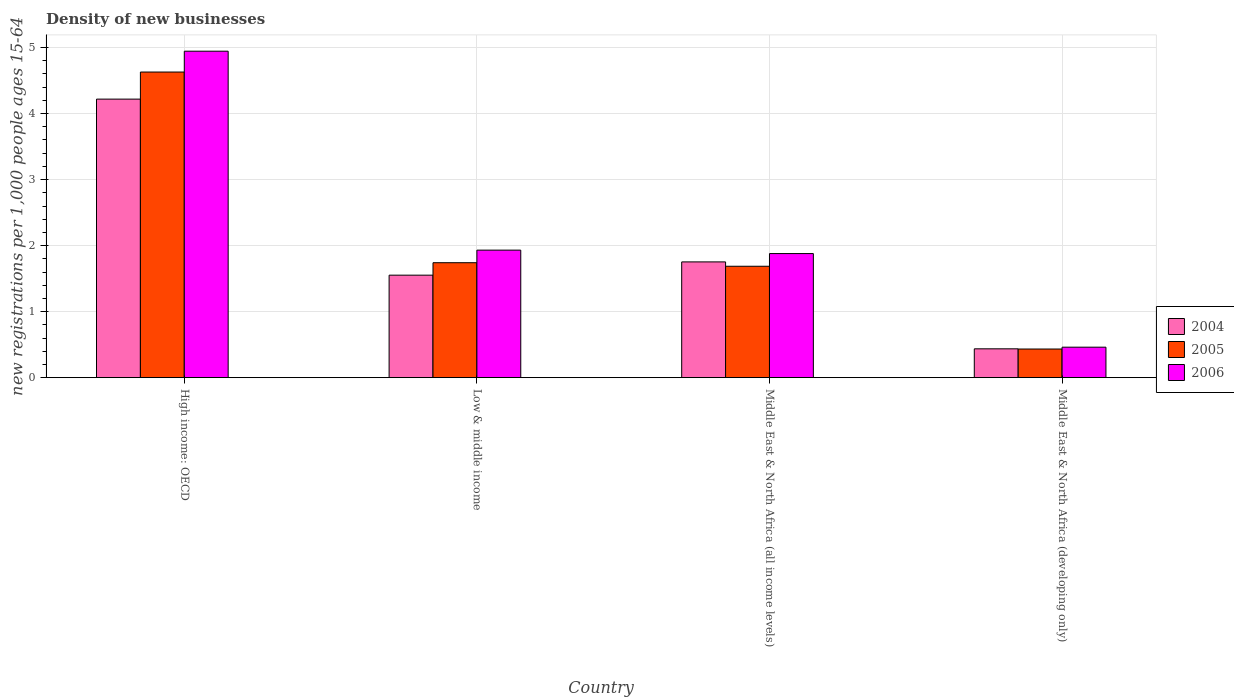Are the number of bars per tick equal to the number of legend labels?
Your answer should be compact. Yes. How many bars are there on the 4th tick from the right?
Provide a succinct answer. 3. What is the label of the 1st group of bars from the left?
Your response must be concise. High income: OECD. What is the number of new registrations in 2006 in Middle East & North Africa (developing only)?
Provide a succinct answer. 0.46. Across all countries, what is the maximum number of new registrations in 2006?
Make the answer very short. 4.94. Across all countries, what is the minimum number of new registrations in 2006?
Your answer should be compact. 0.46. In which country was the number of new registrations in 2006 maximum?
Offer a very short reply. High income: OECD. In which country was the number of new registrations in 2005 minimum?
Your answer should be compact. Middle East & North Africa (developing only). What is the total number of new registrations in 2004 in the graph?
Offer a very short reply. 7.96. What is the difference between the number of new registrations in 2005 in Low & middle income and that in Middle East & North Africa (all income levels)?
Offer a very short reply. 0.05. What is the difference between the number of new registrations in 2006 in Middle East & North Africa (all income levels) and the number of new registrations in 2004 in Middle East & North Africa (developing only)?
Give a very brief answer. 1.44. What is the average number of new registrations in 2005 per country?
Ensure brevity in your answer.  2.12. What is the difference between the number of new registrations of/in 2004 and number of new registrations of/in 2005 in Middle East & North Africa (developing only)?
Keep it short and to the point. 0. In how many countries, is the number of new registrations in 2004 greater than 2.6?
Keep it short and to the point. 1. What is the ratio of the number of new registrations in 2004 in Middle East & North Africa (all income levels) to that in Middle East & North Africa (developing only)?
Give a very brief answer. 4.01. Is the difference between the number of new registrations in 2004 in High income: OECD and Middle East & North Africa (developing only) greater than the difference between the number of new registrations in 2005 in High income: OECD and Middle East & North Africa (developing only)?
Ensure brevity in your answer.  No. What is the difference between the highest and the second highest number of new registrations in 2004?
Ensure brevity in your answer.  -2.47. What is the difference between the highest and the lowest number of new registrations in 2004?
Make the answer very short. 3.78. In how many countries, is the number of new registrations in 2005 greater than the average number of new registrations in 2005 taken over all countries?
Offer a terse response. 1. Is the sum of the number of new registrations in 2005 in High income: OECD and Middle East & North Africa (developing only) greater than the maximum number of new registrations in 2004 across all countries?
Make the answer very short. Yes. What does the 2nd bar from the right in High income: OECD represents?
Offer a terse response. 2005. Is it the case that in every country, the sum of the number of new registrations in 2004 and number of new registrations in 2006 is greater than the number of new registrations in 2005?
Your answer should be very brief. Yes. How many countries are there in the graph?
Provide a succinct answer. 4. What is the difference between two consecutive major ticks on the Y-axis?
Your answer should be very brief. 1. Are the values on the major ticks of Y-axis written in scientific E-notation?
Offer a terse response. No. Does the graph contain any zero values?
Provide a succinct answer. No. Does the graph contain grids?
Make the answer very short. Yes. Where does the legend appear in the graph?
Provide a short and direct response. Center right. How are the legend labels stacked?
Ensure brevity in your answer.  Vertical. What is the title of the graph?
Your answer should be compact. Density of new businesses. Does "1963" appear as one of the legend labels in the graph?
Provide a short and direct response. No. What is the label or title of the X-axis?
Provide a short and direct response. Country. What is the label or title of the Y-axis?
Give a very brief answer. New registrations per 1,0 people ages 15-64. What is the new registrations per 1,000 people ages 15-64 of 2004 in High income: OECD?
Offer a terse response. 4.22. What is the new registrations per 1,000 people ages 15-64 of 2005 in High income: OECD?
Offer a terse response. 4.63. What is the new registrations per 1,000 people ages 15-64 in 2006 in High income: OECD?
Provide a succinct answer. 4.94. What is the new registrations per 1,000 people ages 15-64 in 2004 in Low & middle income?
Ensure brevity in your answer.  1.55. What is the new registrations per 1,000 people ages 15-64 of 2005 in Low & middle income?
Offer a very short reply. 1.74. What is the new registrations per 1,000 people ages 15-64 in 2006 in Low & middle income?
Your answer should be compact. 1.93. What is the new registrations per 1,000 people ages 15-64 in 2004 in Middle East & North Africa (all income levels)?
Offer a very short reply. 1.75. What is the new registrations per 1,000 people ages 15-64 of 2005 in Middle East & North Africa (all income levels)?
Give a very brief answer. 1.69. What is the new registrations per 1,000 people ages 15-64 of 2006 in Middle East & North Africa (all income levels)?
Offer a very short reply. 1.88. What is the new registrations per 1,000 people ages 15-64 in 2004 in Middle East & North Africa (developing only)?
Your response must be concise. 0.44. What is the new registrations per 1,000 people ages 15-64 of 2005 in Middle East & North Africa (developing only)?
Keep it short and to the point. 0.43. What is the new registrations per 1,000 people ages 15-64 of 2006 in Middle East & North Africa (developing only)?
Make the answer very short. 0.46. Across all countries, what is the maximum new registrations per 1,000 people ages 15-64 in 2004?
Offer a very short reply. 4.22. Across all countries, what is the maximum new registrations per 1,000 people ages 15-64 in 2005?
Provide a succinct answer. 4.63. Across all countries, what is the maximum new registrations per 1,000 people ages 15-64 of 2006?
Keep it short and to the point. 4.94. Across all countries, what is the minimum new registrations per 1,000 people ages 15-64 of 2004?
Your answer should be compact. 0.44. Across all countries, what is the minimum new registrations per 1,000 people ages 15-64 in 2005?
Give a very brief answer. 0.43. Across all countries, what is the minimum new registrations per 1,000 people ages 15-64 of 2006?
Offer a terse response. 0.46. What is the total new registrations per 1,000 people ages 15-64 of 2004 in the graph?
Your response must be concise. 7.96. What is the total new registrations per 1,000 people ages 15-64 in 2005 in the graph?
Keep it short and to the point. 8.49. What is the total new registrations per 1,000 people ages 15-64 of 2006 in the graph?
Ensure brevity in your answer.  9.22. What is the difference between the new registrations per 1,000 people ages 15-64 in 2004 in High income: OECD and that in Low & middle income?
Make the answer very short. 2.67. What is the difference between the new registrations per 1,000 people ages 15-64 of 2005 in High income: OECD and that in Low & middle income?
Provide a succinct answer. 2.89. What is the difference between the new registrations per 1,000 people ages 15-64 in 2006 in High income: OECD and that in Low & middle income?
Offer a terse response. 3.01. What is the difference between the new registrations per 1,000 people ages 15-64 in 2004 in High income: OECD and that in Middle East & North Africa (all income levels)?
Your answer should be compact. 2.47. What is the difference between the new registrations per 1,000 people ages 15-64 of 2005 in High income: OECD and that in Middle East & North Africa (all income levels)?
Make the answer very short. 2.94. What is the difference between the new registrations per 1,000 people ages 15-64 in 2006 in High income: OECD and that in Middle East & North Africa (all income levels)?
Give a very brief answer. 3.07. What is the difference between the new registrations per 1,000 people ages 15-64 of 2004 in High income: OECD and that in Middle East & North Africa (developing only)?
Provide a short and direct response. 3.78. What is the difference between the new registrations per 1,000 people ages 15-64 of 2005 in High income: OECD and that in Middle East & North Africa (developing only)?
Provide a short and direct response. 4.2. What is the difference between the new registrations per 1,000 people ages 15-64 in 2006 in High income: OECD and that in Middle East & North Africa (developing only)?
Your answer should be very brief. 4.48. What is the difference between the new registrations per 1,000 people ages 15-64 in 2004 in Low & middle income and that in Middle East & North Africa (all income levels)?
Give a very brief answer. -0.2. What is the difference between the new registrations per 1,000 people ages 15-64 of 2005 in Low & middle income and that in Middle East & North Africa (all income levels)?
Ensure brevity in your answer.  0.05. What is the difference between the new registrations per 1,000 people ages 15-64 in 2006 in Low & middle income and that in Middle East & North Africa (all income levels)?
Offer a terse response. 0.05. What is the difference between the new registrations per 1,000 people ages 15-64 of 2004 in Low & middle income and that in Middle East & North Africa (developing only)?
Ensure brevity in your answer.  1.12. What is the difference between the new registrations per 1,000 people ages 15-64 in 2005 in Low & middle income and that in Middle East & North Africa (developing only)?
Provide a short and direct response. 1.31. What is the difference between the new registrations per 1,000 people ages 15-64 of 2006 in Low & middle income and that in Middle East & North Africa (developing only)?
Provide a succinct answer. 1.47. What is the difference between the new registrations per 1,000 people ages 15-64 of 2004 in Middle East & North Africa (all income levels) and that in Middle East & North Africa (developing only)?
Your answer should be compact. 1.32. What is the difference between the new registrations per 1,000 people ages 15-64 of 2005 in Middle East & North Africa (all income levels) and that in Middle East & North Africa (developing only)?
Offer a very short reply. 1.25. What is the difference between the new registrations per 1,000 people ages 15-64 of 2006 in Middle East & North Africa (all income levels) and that in Middle East & North Africa (developing only)?
Your response must be concise. 1.42. What is the difference between the new registrations per 1,000 people ages 15-64 of 2004 in High income: OECD and the new registrations per 1,000 people ages 15-64 of 2005 in Low & middle income?
Your answer should be compact. 2.48. What is the difference between the new registrations per 1,000 people ages 15-64 of 2004 in High income: OECD and the new registrations per 1,000 people ages 15-64 of 2006 in Low & middle income?
Your response must be concise. 2.29. What is the difference between the new registrations per 1,000 people ages 15-64 in 2005 in High income: OECD and the new registrations per 1,000 people ages 15-64 in 2006 in Low & middle income?
Make the answer very short. 2.7. What is the difference between the new registrations per 1,000 people ages 15-64 of 2004 in High income: OECD and the new registrations per 1,000 people ages 15-64 of 2005 in Middle East & North Africa (all income levels)?
Your response must be concise. 2.53. What is the difference between the new registrations per 1,000 people ages 15-64 of 2004 in High income: OECD and the new registrations per 1,000 people ages 15-64 of 2006 in Middle East & North Africa (all income levels)?
Your answer should be compact. 2.34. What is the difference between the new registrations per 1,000 people ages 15-64 in 2005 in High income: OECD and the new registrations per 1,000 people ages 15-64 in 2006 in Middle East & North Africa (all income levels)?
Your answer should be compact. 2.75. What is the difference between the new registrations per 1,000 people ages 15-64 of 2004 in High income: OECD and the new registrations per 1,000 people ages 15-64 of 2005 in Middle East & North Africa (developing only)?
Your answer should be very brief. 3.79. What is the difference between the new registrations per 1,000 people ages 15-64 in 2004 in High income: OECD and the new registrations per 1,000 people ages 15-64 in 2006 in Middle East & North Africa (developing only)?
Your answer should be very brief. 3.76. What is the difference between the new registrations per 1,000 people ages 15-64 in 2005 in High income: OECD and the new registrations per 1,000 people ages 15-64 in 2006 in Middle East & North Africa (developing only)?
Your answer should be very brief. 4.17. What is the difference between the new registrations per 1,000 people ages 15-64 of 2004 in Low & middle income and the new registrations per 1,000 people ages 15-64 of 2005 in Middle East & North Africa (all income levels)?
Provide a succinct answer. -0.13. What is the difference between the new registrations per 1,000 people ages 15-64 in 2004 in Low & middle income and the new registrations per 1,000 people ages 15-64 in 2006 in Middle East & North Africa (all income levels)?
Give a very brief answer. -0.33. What is the difference between the new registrations per 1,000 people ages 15-64 in 2005 in Low & middle income and the new registrations per 1,000 people ages 15-64 in 2006 in Middle East & North Africa (all income levels)?
Make the answer very short. -0.14. What is the difference between the new registrations per 1,000 people ages 15-64 of 2004 in Low & middle income and the new registrations per 1,000 people ages 15-64 of 2005 in Middle East & North Africa (developing only)?
Give a very brief answer. 1.12. What is the difference between the new registrations per 1,000 people ages 15-64 in 2004 in Low & middle income and the new registrations per 1,000 people ages 15-64 in 2006 in Middle East & North Africa (developing only)?
Keep it short and to the point. 1.09. What is the difference between the new registrations per 1,000 people ages 15-64 in 2005 in Low & middle income and the new registrations per 1,000 people ages 15-64 in 2006 in Middle East & North Africa (developing only)?
Offer a terse response. 1.28. What is the difference between the new registrations per 1,000 people ages 15-64 of 2004 in Middle East & North Africa (all income levels) and the new registrations per 1,000 people ages 15-64 of 2005 in Middle East & North Africa (developing only)?
Ensure brevity in your answer.  1.32. What is the difference between the new registrations per 1,000 people ages 15-64 in 2004 in Middle East & North Africa (all income levels) and the new registrations per 1,000 people ages 15-64 in 2006 in Middle East & North Africa (developing only)?
Your answer should be compact. 1.29. What is the difference between the new registrations per 1,000 people ages 15-64 of 2005 in Middle East & North Africa (all income levels) and the new registrations per 1,000 people ages 15-64 of 2006 in Middle East & North Africa (developing only)?
Provide a short and direct response. 1.23. What is the average new registrations per 1,000 people ages 15-64 of 2004 per country?
Make the answer very short. 1.99. What is the average new registrations per 1,000 people ages 15-64 in 2005 per country?
Ensure brevity in your answer.  2.12. What is the average new registrations per 1,000 people ages 15-64 of 2006 per country?
Your answer should be compact. 2.3. What is the difference between the new registrations per 1,000 people ages 15-64 in 2004 and new registrations per 1,000 people ages 15-64 in 2005 in High income: OECD?
Make the answer very short. -0.41. What is the difference between the new registrations per 1,000 people ages 15-64 of 2004 and new registrations per 1,000 people ages 15-64 of 2006 in High income: OECD?
Provide a succinct answer. -0.73. What is the difference between the new registrations per 1,000 people ages 15-64 in 2005 and new registrations per 1,000 people ages 15-64 in 2006 in High income: OECD?
Provide a succinct answer. -0.32. What is the difference between the new registrations per 1,000 people ages 15-64 of 2004 and new registrations per 1,000 people ages 15-64 of 2005 in Low & middle income?
Offer a terse response. -0.19. What is the difference between the new registrations per 1,000 people ages 15-64 in 2004 and new registrations per 1,000 people ages 15-64 in 2006 in Low & middle income?
Offer a terse response. -0.38. What is the difference between the new registrations per 1,000 people ages 15-64 in 2005 and new registrations per 1,000 people ages 15-64 in 2006 in Low & middle income?
Ensure brevity in your answer.  -0.19. What is the difference between the new registrations per 1,000 people ages 15-64 of 2004 and new registrations per 1,000 people ages 15-64 of 2005 in Middle East & North Africa (all income levels)?
Provide a succinct answer. 0.07. What is the difference between the new registrations per 1,000 people ages 15-64 of 2004 and new registrations per 1,000 people ages 15-64 of 2006 in Middle East & North Africa (all income levels)?
Ensure brevity in your answer.  -0.13. What is the difference between the new registrations per 1,000 people ages 15-64 in 2005 and new registrations per 1,000 people ages 15-64 in 2006 in Middle East & North Africa (all income levels)?
Offer a terse response. -0.19. What is the difference between the new registrations per 1,000 people ages 15-64 of 2004 and new registrations per 1,000 people ages 15-64 of 2005 in Middle East & North Africa (developing only)?
Offer a very short reply. 0. What is the difference between the new registrations per 1,000 people ages 15-64 in 2004 and new registrations per 1,000 people ages 15-64 in 2006 in Middle East & North Africa (developing only)?
Your response must be concise. -0.02. What is the difference between the new registrations per 1,000 people ages 15-64 of 2005 and new registrations per 1,000 people ages 15-64 of 2006 in Middle East & North Africa (developing only)?
Your answer should be very brief. -0.03. What is the ratio of the new registrations per 1,000 people ages 15-64 in 2004 in High income: OECD to that in Low & middle income?
Your answer should be compact. 2.72. What is the ratio of the new registrations per 1,000 people ages 15-64 of 2005 in High income: OECD to that in Low & middle income?
Keep it short and to the point. 2.66. What is the ratio of the new registrations per 1,000 people ages 15-64 of 2006 in High income: OECD to that in Low & middle income?
Your answer should be compact. 2.56. What is the ratio of the new registrations per 1,000 people ages 15-64 in 2004 in High income: OECD to that in Middle East & North Africa (all income levels)?
Your response must be concise. 2.41. What is the ratio of the new registrations per 1,000 people ages 15-64 of 2005 in High income: OECD to that in Middle East & North Africa (all income levels)?
Offer a terse response. 2.74. What is the ratio of the new registrations per 1,000 people ages 15-64 of 2006 in High income: OECD to that in Middle East & North Africa (all income levels)?
Provide a succinct answer. 2.63. What is the ratio of the new registrations per 1,000 people ages 15-64 in 2004 in High income: OECD to that in Middle East & North Africa (developing only)?
Provide a short and direct response. 9.66. What is the ratio of the new registrations per 1,000 people ages 15-64 in 2005 in High income: OECD to that in Middle East & North Africa (developing only)?
Give a very brief answer. 10.67. What is the ratio of the new registrations per 1,000 people ages 15-64 of 2006 in High income: OECD to that in Middle East & North Africa (developing only)?
Offer a terse response. 10.71. What is the ratio of the new registrations per 1,000 people ages 15-64 in 2004 in Low & middle income to that in Middle East & North Africa (all income levels)?
Offer a very short reply. 0.89. What is the ratio of the new registrations per 1,000 people ages 15-64 of 2005 in Low & middle income to that in Middle East & North Africa (all income levels)?
Give a very brief answer. 1.03. What is the ratio of the new registrations per 1,000 people ages 15-64 of 2006 in Low & middle income to that in Middle East & North Africa (all income levels)?
Offer a very short reply. 1.03. What is the ratio of the new registrations per 1,000 people ages 15-64 of 2004 in Low & middle income to that in Middle East & North Africa (developing only)?
Your response must be concise. 3.55. What is the ratio of the new registrations per 1,000 people ages 15-64 of 2005 in Low & middle income to that in Middle East & North Africa (developing only)?
Your response must be concise. 4.01. What is the ratio of the new registrations per 1,000 people ages 15-64 of 2006 in Low & middle income to that in Middle East & North Africa (developing only)?
Your answer should be very brief. 4.18. What is the ratio of the new registrations per 1,000 people ages 15-64 in 2004 in Middle East & North Africa (all income levels) to that in Middle East & North Africa (developing only)?
Your answer should be compact. 4.01. What is the ratio of the new registrations per 1,000 people ages 15-64 of 2005 in Middle East & North Africa (all income levels) to that in Middle East & North Africa (developing only)?
Offer a very short reply. 3.89. What is the ratio of the new registrations per 1,000 people ages 15-64 in 2006 in Middle East & North Africa (all income levels) to that in Middle East & North Africa (developing only)?
Provide a succinct answer. 4.07. What is the difference between the highest and the second highest new registrations per 1,000 people ages 15-64 in 2004?
Ensure brevity in your answer.  2.47. What is the difference between the highest and the second highest new registrations per 1,000 people ages 15-64 in 2005?
Make the answer very short. 2.89. What is the difference between the highest and the second highest new registrations per 1,000 people ages 15-64 of 2006?
Provide a succinct answer. 3.01. What is the difference between the highest and the lowest new registrations per 1,000 people ages 15-64 of 2004?
Offer a terse response. 3.78. What is the difference between the highest and the lowest new registrations per 1,000 people ages 15-64 of 2005?
Make the answer very short. 4.2. What is the difference between the highest and the lowest new registrations per 1,000 people ages 15-64 in 2006?
Offer a very short reply. 4.48. 